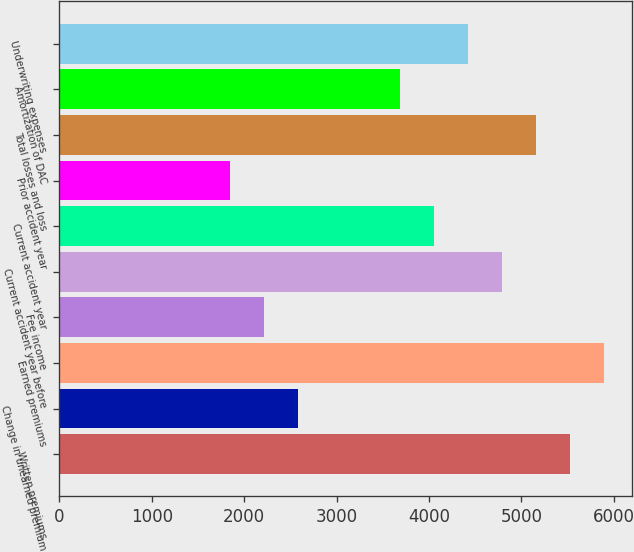Convert chart. <chart><loc_0><loc_0><loc_500><loc_500><bar_chart><fcel>Written premiums<fcel>Change in unearned premium<fcel>Earned premiums<fcel>Fee income<fcel>Current accident year before<fcel>Current accident year<fcel>Prior accident year<fcel>Total losses and loss<fcel>Amortization of DAC<fcel>Underwriting expenses<nl><fcel>5530.5<fcel>2585.7<fcel>5898.6<fcel>2217.6<fcel>4794.3<fcel>4058.1<fcel>1849.5<fcel>5162.4<fcel>3690<fcel>4426.2<nl></chart> 